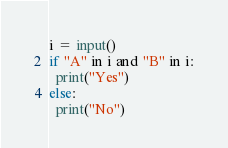<code> <loc_0><loc_0><loc_500><loc_500><_Python_>i = input()
if "A" in i and "B" in i:
  print("Yes")
else:
  print("No")</code> 